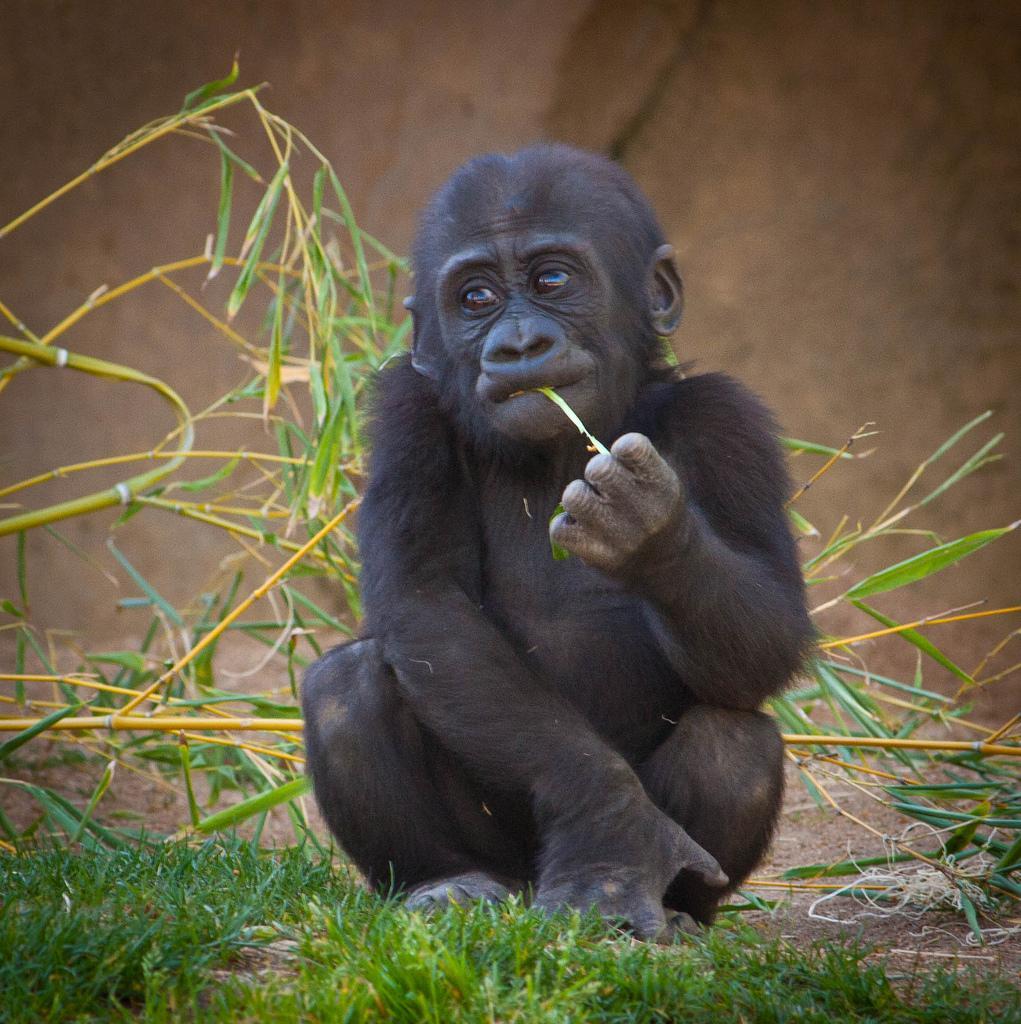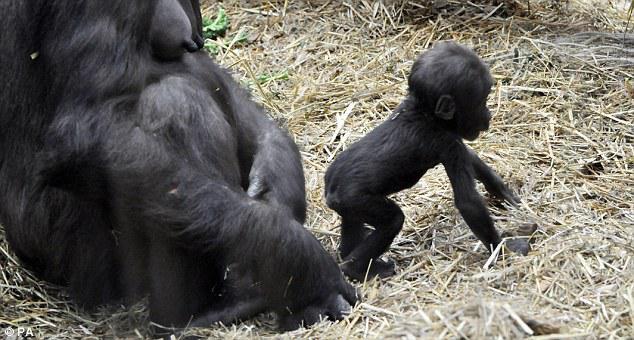The first image is the image on the left, the second image is the image on the right. For the images displayed, is the sentence "Each image features one baby gorilla in contact with one adult gorilla, and one image shows a baby gorilla riding on the back of an adult gorilla." factually correct? Answer yes or no. No. The first image is the image on the left, the second image is the image on the right. For the images shown, is this caption "Both pictures have an adult gorilla with a young gorilla." true? Answer yes or no. No. 